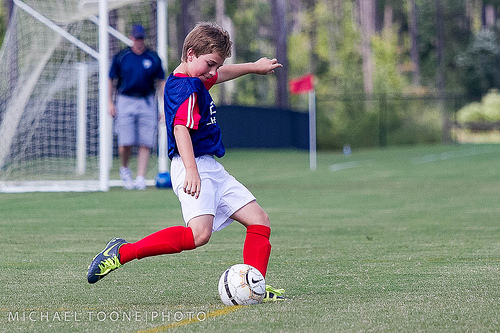<image>
Is there a child in front of the ball? Yes. The child is positioned in front of the ball, appearing closer to the camera viewpoint. 